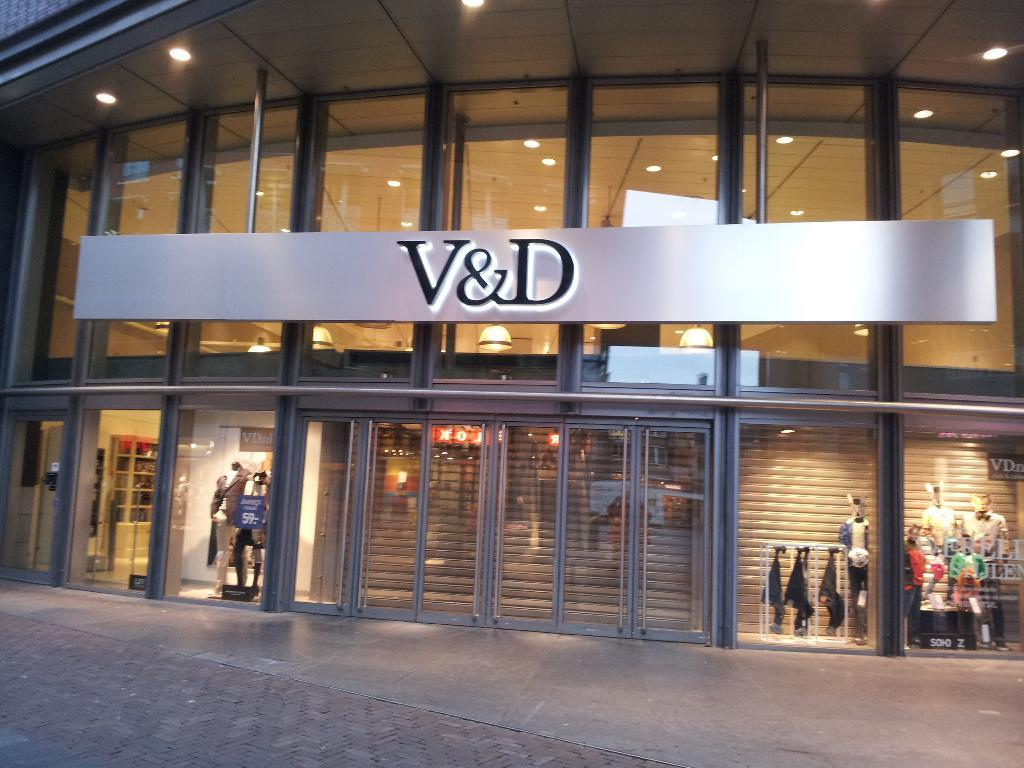What can be seen on the floor in the image? There are mannequins on the floor. What is the purpose of the mannequins in the image? The mannequins are likely used to display clothes. What is the condition of the clothes in the image? The clothes are hanged, suggesting they are on display or being stored. What type of lighting is present in the image? Lights are present, which may be used for illumination or decoration. What is the purpose of the board in the image? The board may be used for displaying information or advertisements. What type of doors are visible in the image? Doors are visible, which may lead to other rooms or areas. What material is present in the image? Glass is present, which may be part of a window or display case. What is the main structure in the image? There is a building in the image, which houses the mannequins, clothes, and other items. What time of day might the image have been taken? The image may have been taken during the night, as indicated by the presence of lights. How does the decision affect the beef in the image? There is no decision or beef present in the image. What type of loss is depicted in the image? There is no loss depicted in the image; it features mannequins, clothes, and other items. 